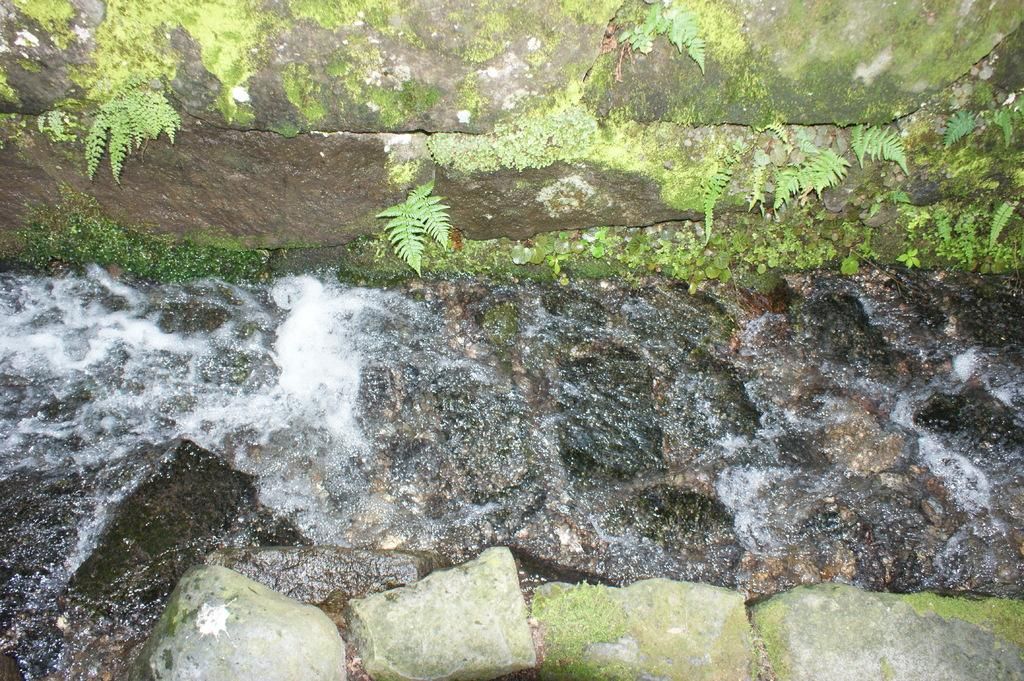What is the primary element visible in the image? There is water in the image. What other objects or features can be seen in the image? There are rocks and leaves in the image. What type of pet is visible in the image? There is no pet present in the image. What organization is responsible for maintaining the area depicted in the image? The image does not provide information about any organization responsible for the area. 